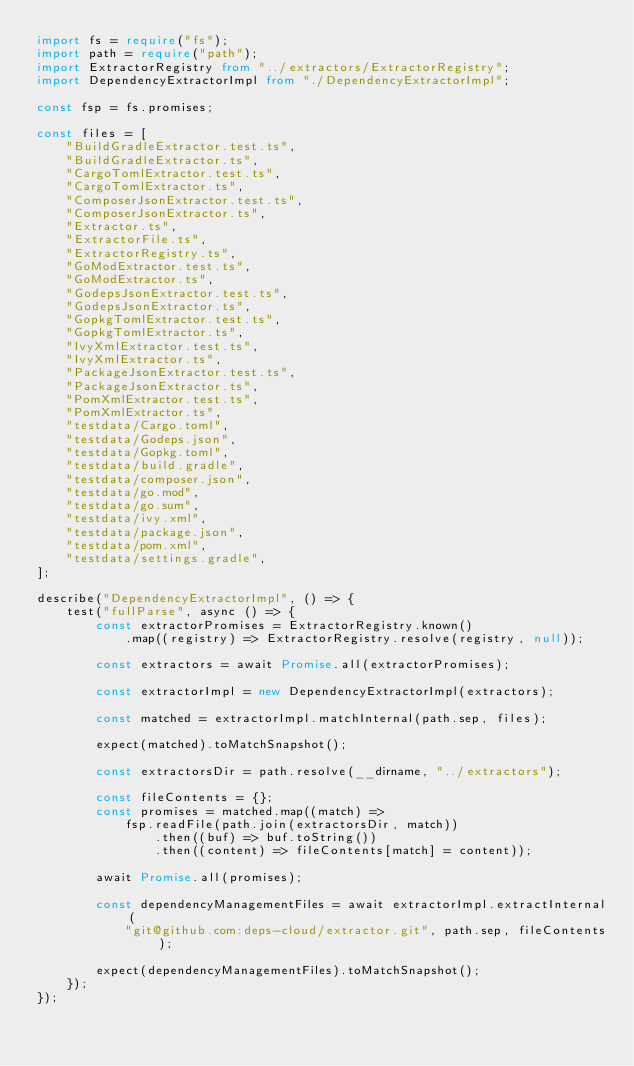Convert code to text. <code><loc_0><loc_0><loc_500><loc_500><_TypeScript_>import fs = require("fs");
import path = require("path");
import ExtractorRegistry from "../extractors/ExtractorRegistry";
import DependencyExtractorImpl from "./DependencyExtractorImpl";

const fsp = fs.promises;

const files = [
    "BuildGradleExtractor.test.ts",
    "BuildGradleExtractor.ts",
    "CargoTomlExtractor.test.ts",
    "CargoTomlExtractor.ts",
    "ComposerJsonExtractor.test.ts",
    "ComposerJsonExtractor.ts",
    "Extractor.ts",
    "ExtractorFile.ts",
    "ExtractorRegistry.ts",
    "GoModExtractor.test.ts",
    "GoModExtractor.ts",
    "GodepsJsonExtractor.test.ts",
    "GodepsJsonExtractor.ts",
    "GopkgTomlExtractor.test.ts",
    "GopkgTomlExtractor.ts",
    "IvyXmlExtractor.test.ts",
    "IvyXmlExtractor.ts",
    "PackageJsonExtractor.test.ts",
    "PackageJsonExtractor.ts",
    "PomXmlExtractor.test.ts",
    "PomXmlExtractor.ts",
    "testdata/Cargo.toml",
    "testdata/Godeps.json",
    "testdata/Gopkg.toml",
    "testdata/build.gradle",
    "testdata/composer.json",
    "testdata/go.mod",
    "testdata/go.sum",
    "testdata/ivy.xml",
    "testdata/package.json",
    "testdata/pom.xml",
    "testdata/settings.gradle",
];

describe("DependencyExtractorImpl", () => {
    test("fullParse", async () => {
        const extractorPromises = ExtractorRegistry.known()
            .map((registry) => ExtractorRegistry.resolve(registry, null));

        const extractors = await Promise.all(extractorPromises);

        const extractorImpl = new DependencyExtractorImpl(extractors);

        const matched = extractorImpl.matchInternal(path.sep, files);

        expect(matched).toMatchSnapshot();

        const extractorsDir = path.resolve(__dirname, "../extractors");

        const fileContents = {};
        const promises = matched.map((match) =>
            fsp.readFile(path.join(extractorsDir, match))
                .then((buf) => buf.toString())
                .then((content) => fileContents[match] = content));

        await Promise.all(promises);

        const dependencyManagementFiles = await extractorImpl.extractInternal(
            "git@github.com:deps-cloud/extractor.git", path.sep, fileContents);

        expect(dependencyManagementFiles).toMatchSnapshot();
    });
});
</code> 